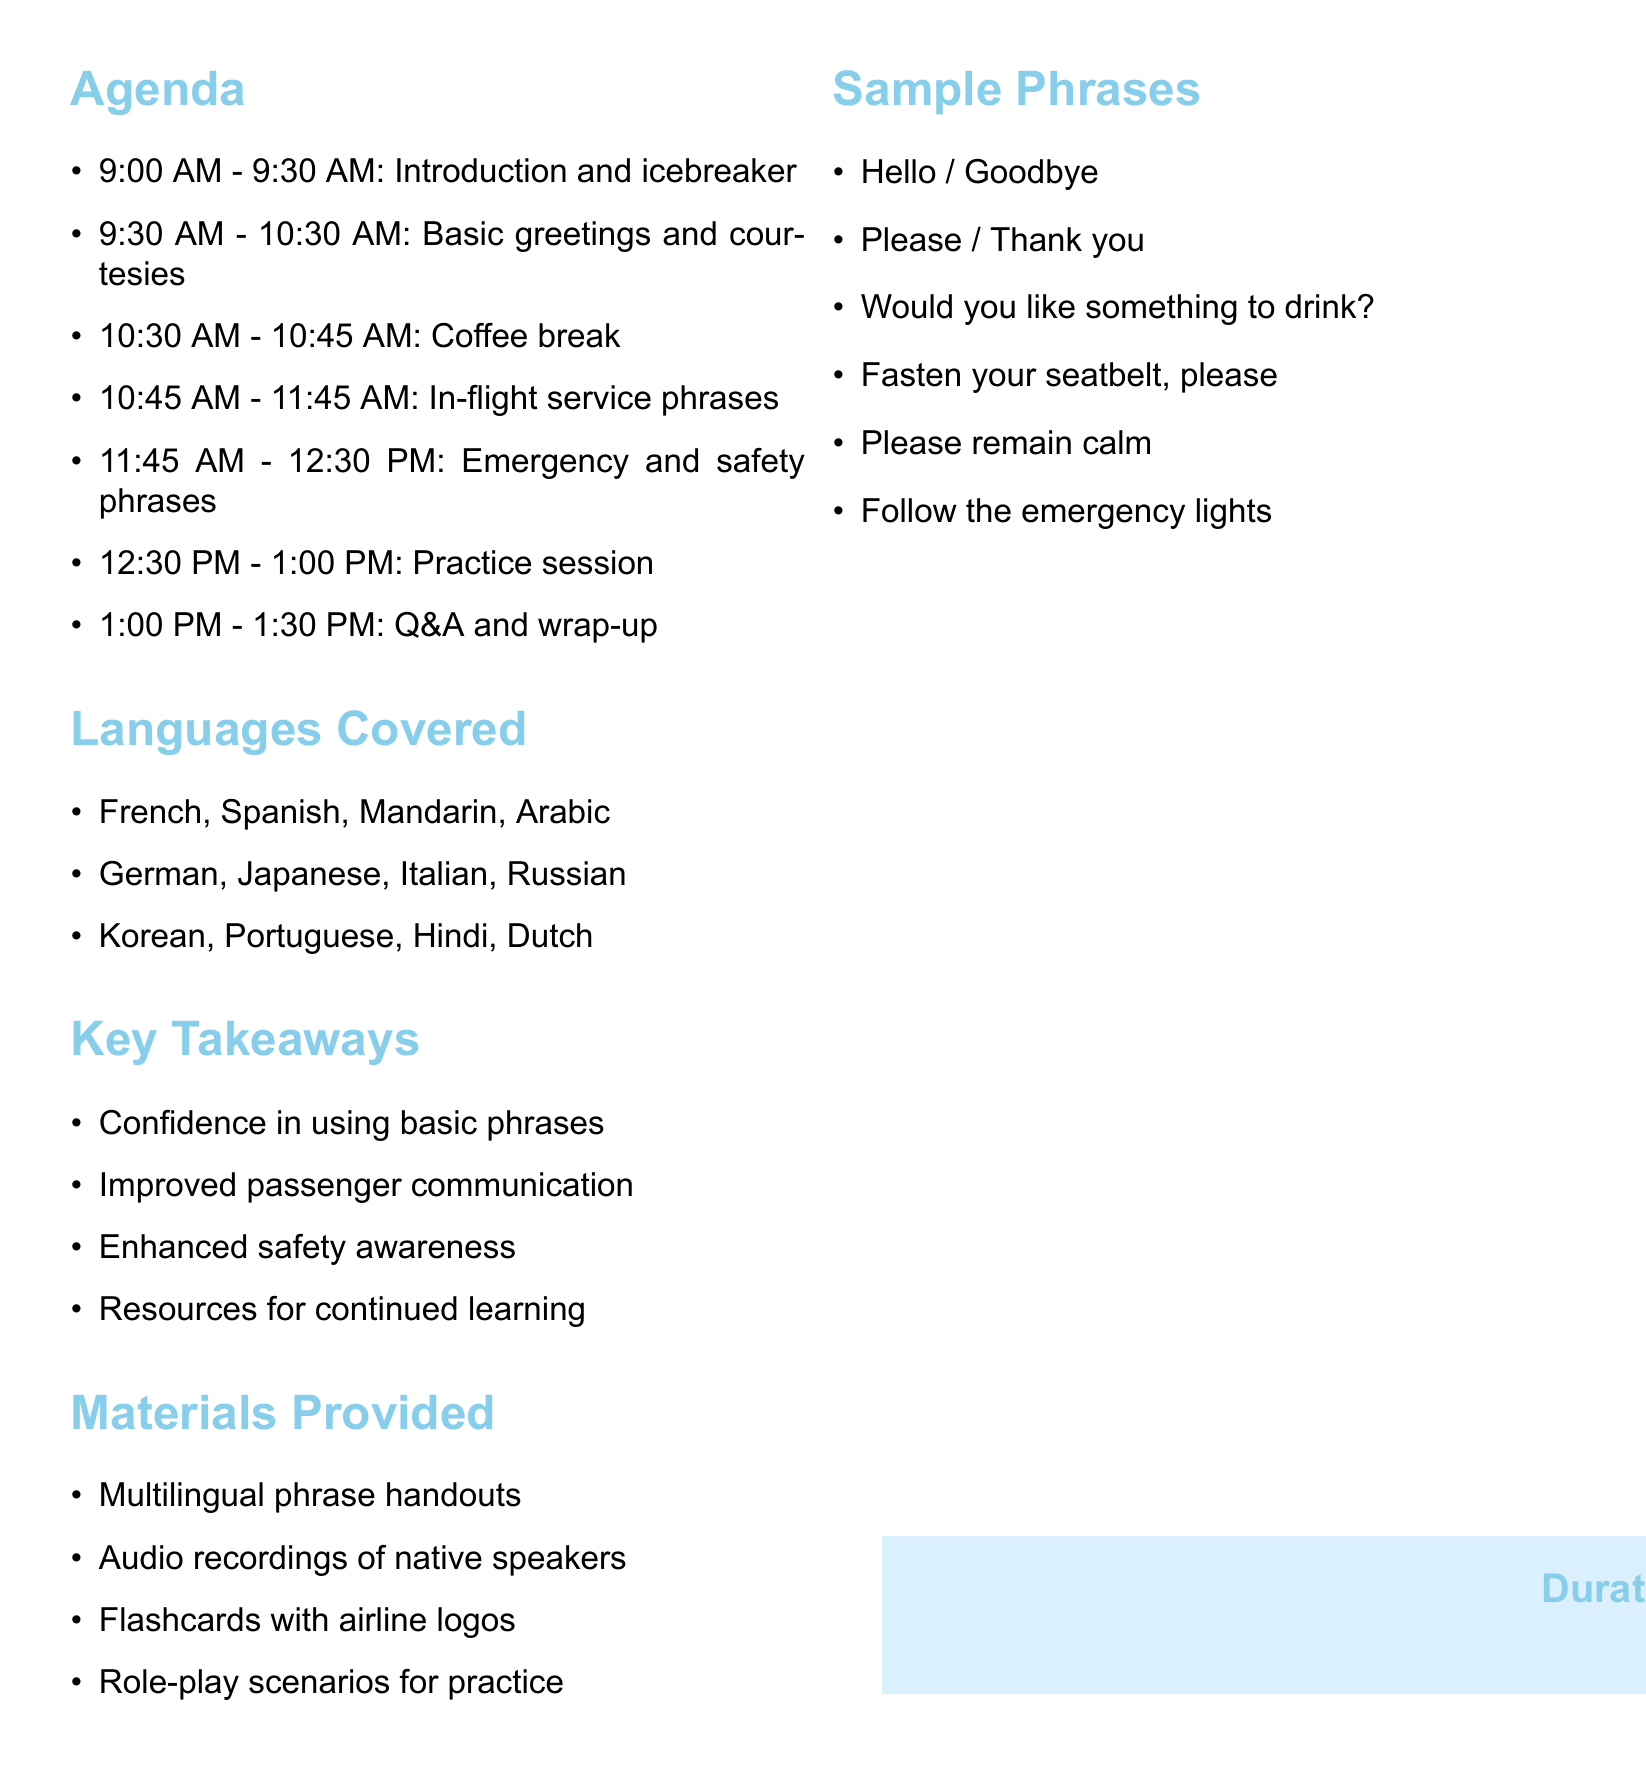What is the title of the workshop? The title of the workshop is stated at the beginning of the document.
Answer: Multilingual Travel Phrases for Flight Attendants How long is the workshop? The duration of the workshop is mentioned clearly in the document.
Answer: 4 hours What activity takes place from 10:45 AM to 11:45 AM? This time slot is allocated for specific activities listed in the agenda.
Answer: In-flight service phrases Which languages are covered during the Basic greetings and courtesies session? The document lists the languages associated with each workshop activity.
Answer: French, Spanish, Mandarin, Arabic What is one of the key takeaways from the workshop? The document provides a list of benefits participants can expect to gain.
Answer: Confidence in using basic phrases What materials are provided for the workshop? A list of provided materials is included in the document.
Answer: Multilingual phrase handouts Which phrase is used to communicate during an emergency? The document includes a specific list of emergency phrases to be used.
Answer: Please remain calm How many coffee breaks are scheduled in the workshop? The number of breaks can be identified in the agenda section.
Answer: 1 